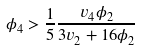<formula> <loc_0><loc_0><loc_500><loc_500>\phi _ { 4 } > \frac { 1 } { 5 } \frac { v _ { 4 } \phi _ { 2 } } { 3 v _ { 2 } + 1 6 \phi _ { 2 } }</formula> 